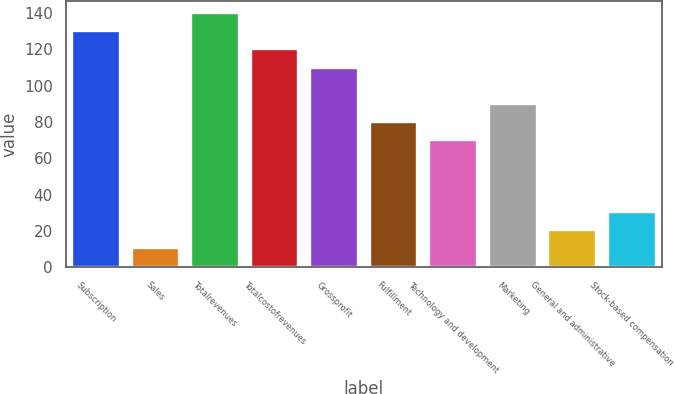<chart> <loc_0><loc_0><loc_500><loc_500><bar_chart><fcel>Subscription<fcel>Sales<fcel>Totalrevenues<fcel>Totalcostofrevenues<fcel>Grossprofit<fcel>Fulfillment<fcel>Technology and development<fcel>Marketing<fcel>General and administrative<fcel>Stock-based compensation<nl><fcel>129.85<fcel>10.45<fcel>139.8<fcel>119.9<fcel>109.95<fcel>80.1<fcel>70.15<fcel>90.05<fcel>20.4<fcel>30.35<nl></chart> 